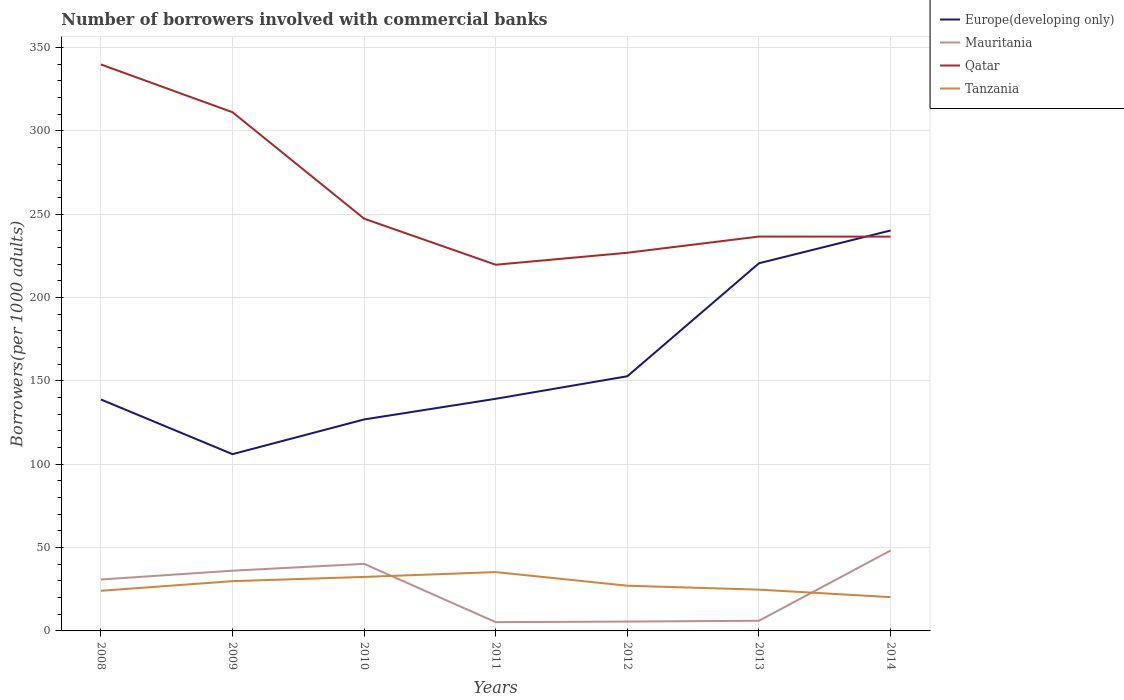How many different coloured lines are there?
Offer a terse response. 4. Across all years, what is the maximum number of borrowers involved with commercial banks in Mauritania?
Your answer should be compact. 5.26. In which year was the number of borrowers involved with commercial banks in Mauritania maximum?
Provide a succinct answer. 2011. What is the total number of borrowers involved with commercial banks in Europe(developing only) in the graph?
Your response must be concise. -93.7. What is the difference between the highest and the second highest number of borrowers involved with commercial banks in Tanzania?
Offer a terse response. 15.03. What is the difference between the highest and the lowest number of borrowers involved with commercial banks in Qatar?
Your answer should be very brief. 2. Is the number of borrowers involved with commercial banks in Mauritania strictly greater than the number of borrowers involved with commercial banks in Tanzania over the years?
Your answer should be very brief. No. Does the graph contain any zero values?
Give a very brief answer. No. Where does the legend appear in the graph?
Ensure brevity in your answer.  Top right. What is the title of the graph?
Keep it short and to the point. Number of borrowers involved with commercial banks. What is the label or title of the X-axis?
Offer a terse response. Years. What is the label or title of the Y-axis?
Give a very brief answer. Borrowers(per 1000 adults). What is the Borrowers(per 1000 adults) of Europe(developing only) in 2008?
Ensure brevity in your answer.  138.85. What is the Borrowers(per 1000 adults) in Mauritania in 2008?
Make the answer very short. 30.85. What is the Borrowers(per 1000 adults) in Qatar in 2008?
Make the answer very short. 339.83. What is the Borrowers(per 1000 adults) of Tanzania in 2008?
Offer a very short reply. 24.08. What is the Borrowers(per 1000 adults) of Europe(developing only) in 2009?
Give a very brief answer. 106.05. What is the Borrowers(per 1000 adults) of Mauritania in 2009?
Your answer should be compact. 36.13. What is the Borrowers(per 1000 adults) of Qatar in 2009?
Your answer should be very brief. 311.18. What is the Borrowers(per 1000 adults) of Tanzania in 2009?
Your response must be concise. 29.86. What is the Borrowers(per 1000 adults) of Europe(developing only) in 2010?
Provide a succinct answer. 126.87. What is the Borrowers(per 1000 adults) in Mauritania in 2010?
Provide a short and direct response. 40.23. What is the Borrowers(per 1000 adults) in Qatar in 2010?
Your response must be concise. 247.33. What is the Borrowers(per 1000 adults) in Tanzania in 2010?
Provide a succinct answer. 32.39. What is the Borrowers(per 1000 adults) in Europe(developing only) in 2011?
Make the answer very short. 139.27. What is the Borrowers(per 1000 adults) in Mauritania in 2011?
Your response must be concise. 5.26. What is the Borrowers(per 1000 adults) in Qatar in 2011?
Keep it short and to the point. 219.67. What is the Borrowers(per 1000 adults) of Tanzania in 2011?
Your answer should be very brief. 35.3. What is the Borrowers(per 1000 adults) in Europe(developing only) in 2012?
Keep it short and to the point. 152.78. What is the Borrowers(per 1000 adults) of Mauritania in 2012?
Your response must be concise. 5.62. What is the Borrowers(per 1000 adults) of Qatar in 2012?
Provide a succinct answer. 226.87. What is the Borrowers(per 1000 adults) of Tanzania in 2012?
Keep it short and to the point. 27.12. What is the Borrowers(per 1000 adults) in Europe(developing only) in 2013?
Provide a succinct answer. 220.56. What is the Borrowers(per 1000 adults) of Mauritania in 2013?
Your answer should be compact. 6.09. What is the Borrowers(per 1000 adults) in Qatar in 2013?
Make the answer very short. 236.58. What is the Borrowers(per 1000 adults) in Tanzania in 2013?
Make the answer very short. 24.77. What is the Borrowers(per 1000 adults) in Europe(developing only) in 2014?
Your answer should be very brief. 240.23. What is the Borrowers(per 1000 adults) in Mauritania in 2014?
Make the answer very short. 48.23. What is the Borrowers(per 1000 adults) in Qatar in 2014?
Offer a very short reply. 236.55. What is the Borrowers(per 1000 adults) of Tanzania in 2014?
Offer a very short reply. 20.27. Across all years, what is the maximum Borrowers(per 1000 adults) in Europe(developing only)?
Provide a succinct answer. 240.23. Across all years, what is the maximum Borrowers(per 1000 adults) of Mauritania?
Your answer should be compact. 48.23. Across all years, what is the maximum Borrowers(per 1000 adults) in Qatar?
Offer a very short reply. 339.83. Across all years, what is the maximum Borrowers(per 1000 adults) in Tanzania?
Provide a succinct answer. 35.3. Across all years, what is the minimum Borrowers(per 1000 adults) of Europe(developing only)?
Keep it short and to the point. 106.05. Across all years, what is the minimum Borrowers(per 1000 adults) in Mauritania?
Provide a short and direct response. 5.26. Across all years, what is the minimum Borrowers(per 1000 adults) of Qatar?
Ensure brevity in your answer.  219.67. Across all years, what is the minimum Borrowers(per 1000 adults) of Tanzania?
Your answer should be compact. 20.27. What is the total Borrowers(per 1000 adults) of Europe(developing only) in the graph?
Provide a succinct answer. 1124.6. What is the total Borrowers(per 1000 adults) of Mauritania in the graph?
Make the answer very short. 172.4. What is the total Borrowers(per 1000 adults) in Qatar in the graph?
Give a very brief answer. 1818.02. What is the total Borrowers(per 1000 adults) in Tanzania in the graph?
Provide a short and direct response. 193.77. What is the difference between the Borrowers(per 1000 adults) of Europe(developing only) in 2008 and that in 2009?
Keep it short and to the point. 32.8. What is the difference between the Borrowers(per 1000 adults) of Mauritania in 2008 and that in 2009?
Provide a succinct answer. -5.28. What is the difference between the Borrowers(per 1000 adults) in Qatar in 2008 and that in 2009?
Provide a short and direct response. 28.65. What is the difference between the Borrowers(per 1000 adults) of Tanzania in 2008 and that in 2009?
Provide a short and direct response. -5.78. What is the difference between the Borrowers(per 1000 adults) in Europe(developing only) in 2008 and that in 2010?
Ensure brevity in your answer.  11.98. What is the difference between the Borrowers(per 1000 adults) of Mauritania in 2008 and that in 2010?
Provide a short and direct response. -9.38. What is the difference between the Borrowers(per 1000 adults) in Qatar in 2008 and that in 2010?
Keep it short and to the point. 92.5. What is the difference between the Borrowers(per 1000 adults) in Tanzania in 2008 and that in 2010?
Your answer should be very brief. -8.32. What is the difference between the Borrowers(per 1000 adults) in Europe(developing only) in 2008 and that in 2011?
Keep it short and to the point. -0.42. What is the difference between the Borrowers(per 1000 adults) in Mauritania in 2008 and that in 2011?
Make the answer very short. 25.59. What is the difference between the Borrowers(per 1000 adults) of Qatar in 2008 and that in 2011?
Ensure brevity in your answer.  120.16. What is the difference between the Borrowers(per 1000 adults) of Tanzania in 2008 and that in 2011?
Provide a succinct answer. -11.22. What is the difference between the Borrowers(per 1000 adults) in Europe(developing only) in 2008 and that in 2012?
Ensure brevity in your answer.  -13.93. What is the difference between the Borrowers(per 1000 adults) in Mauritania in 2008 and that in 2012?
Offer a terse response. 25.23. What is the difference between the Borrowers(per 1000 adults) in Qatar in 2008 and that in 2012?
Offer a terse response. 112.96. What is the difference between the Borrowers(per 1000 adults) of Tanzania in 2008 and that in 2012?
Keep it short and to the point. -3.04. What is the difference between the Borrowers(per 1000 adults) of Europe(developing only) in 2008 and that in 2013?
Give a very brief answer. -81.71. What is the difference between the Borrowers(per 1000 adults) in Mauritania in 2008 and that in 2013?
Ensure brevity in your answer.  24.76. What is the difference between the Borrowers(per 1000 adults) of Qatar in 2008 and that in 2013?
Provide a succinct answer. 103.25. What is the difference between the Borrowers(per 1000 adults) of Tanzania in 2008 and that in 2013?
Provide a succinct answer. -0.69. What is the difference between the Borrowers(per 1000 adults) in Europe(developing only) in 2008 and that in 2014?
Offer a terse response. -101.38. What is the difference between the Borrowers(per 1000 adults) of Mauritania in 2008 and that in 2014?
Your answer should be compact. -17.38. What is the difference between the Borrowers(per 1000 adults) in Qatar in 2008 and that in 2014?
Keep it short and to the point. 103.28. What is the difference between the Borrowers(per 1000 adults) in Tanzania in 2008 and that in 2014?
Offer a terse response. 3.81. What is the difference between the Borrowers(per 1000 adults) of Europe(developing only) in 2009 and that in 2010?
Your response must be concise. -20.82. What is the difference between the Borrowers(per 1000 adults) in Mauritania in 2009 and that in 2010?
Ensure brevity in your answer.  -4.1. What is the difference between the Borrowers(per 1000 adults) of Qatar in 2009 and that in 2010?
Make the answer very short. 63.85. What is the difference between the Borrowers(per 1000 adults) of Tanzania in 2009 and that in 2010?
Provide a short and direct response. -2.54. What is the difference between the Borrowers(per 1000 adults) in Europe(developing only) in 2009 and that in 2011?
Offer a terse response. -33.22. What is the difference between the Borrowers(per 1000 adults) in Mauritania in 2009 and that in 2011?
Provide a short and direct response. 30.88. What is the difference between the Borrowers(per 1000 adults) in Qatar in 2009 and that in 2011?
Ensure brevity in your answer.  91.51. What is the difference between the Borrowers(per 1000 adults) of Tanzania in 2009 and that in 2011?
Ensure brevity in your answer.  -5.44. What is the difference between the Borrowers(per 1000 adults) in Europe(developing only) in 2009 and that in 2012?
Ensure brevity in your answer.  -46.73. What is the difference between the Borrowers(per 1000 adults) of Mauritania in 2009 and that in 2012?
Ensure brevity in your answer.  30.51. What is the difference between the Borrowers(per 1000 adults) of Qatar in 2009 and that in 2012?
Your answer should be compact. 84.31. What is the difference between the Borrowers(per 1000 adults) of Tanzania in 2009 and that in 2012?
Give a very brief answer. 2.74. What is the difference between the Borrowers(per 1000 adults) of Europe(developing only) in 2009 and that in 2013?
Provide a short and direct response. -114.52. What is the difference between the Borrowers(per 1000 adults) of Mauritania in 2009 and that in 2013?
Offer a very short reply. 30.04. What is the difference between the Borrowers(per 1000 adults) in Qatar in 2009 and that in 2013?
Ensure brevity in your answer.  74.6. What is the difference between the Borrowers(per 1000 adults) in Tanzania in 2009 and that in 2013?
Offer a very short reply. 5.09. What is the difference between the Borrowers(per 1000 adults) in Europe(developing only) in 2009 and that in 2014?
Make the answer very short. -134.19. What is the difference between the Borrowers(per 1000 adults) in Mauritania in 2009 and that in 2014?
Your answer should be very brief. -12.1. What is the difference between the Borrowers(per 1000 adults) of Qatar in 2009 and that in 2014?
Ensure brevity in your answer.  74.63. What is the difference between the Borrowers(per 1000 adults) in Tanzania in 2009 and that in 2014?
Make the answer very short. 9.59. What is the difference between the Borrowers(per 1000 adults) in Europe(developing only) in 2010 and that in 2011?
Your response must be concise. -12.4. What is the difference between the Borrowers(per 1000 adults) of Mauritania in 2010 and that in 2011?
Provide a succinct answer. 34.97. What is the difference between the Borrowers(per 1000 adults) in Qatar in 2010 and that in 2011?
Offer a terse response. 27.65. What is the difference between the Borrowers(per 1000 adults) in Tanzania in 2010 and that in 2011?
Give a very brief answer. -2.91. What is the difference between the Borrowers(per 1000 adults) in Europe(developing only) in 2010 and that in 2012?
Make the answer very short. -25.91. What is the difference between the Borrowers(per 1000 adults) in Mauritania in 2010 and that in 2012?
Keep it short and to the point. 34.61. What is the difference between the Borrowers(per 1000 adults) in Qatar in 2010 and that in 2012?
Give a very brief answer. 20.46. What is the difference between the Borrowers(per 1000 adults) of Tanzania in 2010 and that in 2012?
Ensure brevity in your answer.  5.28. What is the difference between the Borrowers(per 1000 adults) in Europe(developing only) in 2010 and that in 2013?
Offer a very short reply. -93.7. What is the difference between the Borrowers(per 1000 adults) in Mauritania in 2010 and that in 2013?
Offer a very short reply. 34.14. What is the difference between the Borrowers(per 1000 adults) of Qatar in 2010 and that in 2013?
Make the answer very short. 10.74. What is the difference between the Borrowers(per 1000 adults) in Tanzania in 2010 and that in 2013?
Your answer should be compact. 7.63. What is the difference between the Borrowers(per 1000 adults) in Europe(developing only) in 2010 and that in 2014?
Give a very brief answer. -113.37. What is the difference between the Borrowers(per 1000 adults) in Mauritania in 2010 and that in 2014?
Give a very brief answer. -8. What is the difference between the Borrowers(per 1000 adults) of Qatar in 2010 and that in 2014?
Your response must be concise. 10.78. What is the difference between the Borrowers(per 1000 adults) of Tanzania in 2010 and that in 2014?
Provide a succinct answer. 12.12. What is the difference between the Borrowers(per 1000 adults) in Europe(developing only) in 2011 and that in 2012?
Make the answer very short. -13.51. What is the difference between the Borrowers(per 1000 adults) of Mauritania in 2011 and that in 2012?
Provide a succinct answer. -0.36. What is the difference between the Borrowers(per 1000 adults) in Qatar in 2011 and that in 2012?
Offer a terse response. -7.2. What is the difference between the Borrowers(per 1000 adults) of Tanzania in 2011 and that in 2012?
Provide a short and direct response. 8.18. What is the difference between the Borrowers(per 1000 adults) of Europe(developing only) in 2011 and that in 2013?
Offer a terse response. -81.3. What is the difference between the Borrowers(per 1000 adults) of Mauritania in 2011 and that in 2013?
Provide a succinct answer. -0.83. What is the difference between the Borrowers(per 1000 adults) in Qatar in 2011 and that in 2013?
Keep it short and to the point. -16.91. What is the difference between the Borrowers(per 1000 adults) in Tanzania in 2011 and that in 2013?
Your answer should be very brief. 10.53. What is the difference between the Borrowers(per 1000 adults) in Europe(developing only) in 2011 and that in 2014?
Offer a terse response. -100.97. What is the difference between the Borrowers(per 1000 adults) of Mauritania in 2011 and that in 2014?
Offer a very short reply. -42.97. What is the difference between the Borrowers(per 1000 adults) of Qatar in 2011 and that in 2014?
Keep it short and to the point. -16.88. What is the difference between the Borrowers(per 1000 adults) of Tanzania in 2011 and that in 2014?
Make the answer very short. 15.03. What is the difference between the Borrowers(per 1000 adults) of Europe(developing only) in 2012 and that in 2013?
Keep it short and to the point. -67.78. What is the difference between the Borrowers(per 1000 adults) of Mauritania in 2012 and that in 2013?
Provide a succinct answer. -0.47. What is the difference between the Borrowers(per 1000 adults) in Qatar in 2012 and that in 2013?
Offer a terse response. -9.71. What is the difference between the Borrowers(per 1000 adults) in Tanzania in 2012 and that in 2013?
Your answer should be very brief. 2.35. What is the difference between the Borrowers(per 1000 adults) in Europe(developing only) in 2012 and that in 2014?
Provide a succinct answer. -87.45. What is the difference between the Borrowers(per 1000 adults) of Mauritania in 2012 and that in 2014?
Your answer should be compact. -42.61. What is the difference between the Borrowers(per 1000 adults) of Qatar in 2012 and that in 2014?
Ensure brevity in your answer.  -9.68. What is the difference between the Borrowers(per 1000 adults) of Tanzania in 2012 and that in 2014?
Give a very brief answer. 6.85. What is the difference between the Borrowers(per 1000 adults) of Europe(developing only) in 2013 and that in 2014?
Keep it short and to the point. -19.67. What is the difference between the Borrowers(per 1000 adults) in Mauritania in 2013 and that in 2014?
Your response must be concise. -42.14. What is the difference between the Borrowers(per 1000 adults) of Qatar in 2013 and that in 2014?
Provide a short and direct response. 0.04. What is the difference between the Borrowers(per 1000 adults) in Tanzania in 2013 and that in 2014?
Make the answer very short. 4.5. What is the difference between the Borrowers(per 1000 adults) of Europe(developing only) in 2008 and the Borrowers(per 1000 adults) of Mauritania in 2009?
Your answer should be very brief. 102.72. What is the difference between the Borrowers(per 1000 adults) of Europe(developing only) in 2008 and the Borrowers(per 1000 adults) of Qatar in 2009?
Provide a short and direct response. -172.33. What is the difference between the Borrowers(per 1000 adults) of Europe(developing only) in 2008 and the Borrowers(per 1000 adults) of Tanzania in 2009?
Offer a very short reply. 108.99. What is the difference between the Borrowers(per 1000 adults) of Mauritania in 2008 and the Borrowers(per 1000 adults) of Qatar in 2009?
Your answer should be compact. -280.33. What is the difference between the Borrowers(per 1000 adults) of Mauritania in 2008 and the Borrowers(per 1000 adults) of Tanzania in 2009?
Provide a succinct answer. 0.99. What is the difference between the Borrowers(per 1000 adults) of Qatar in 2008 and the Borrowers(per 1000 adults) of Tanzania in 2009?
Keep it short and to the point. 309.98. What is the difference between the Borrowers(per 1000 adults) of Europe(developing only) in 2008 and the Borrowers(per 1000 adults) of Mauritania in 2010?
Make the answer very short. 98.62. What is the difference between the Borrowers(per 1000 adults) in Europe(developing only) in 2008 and the Borrowers(per 1000 adults) in Qatar in 2010?
Give a very brief answer. -108.48. What is the difference between the Borrowers(per 1000 adults) in Europe(developing only) in 2008 and the Borrowers(per 1000 adults) in Tanzania in 2010?
Offer a very short reply. 106.46. What is the difference between the Borrowers(per 1000 adults) of Mauritania in 2008 and the Borrowers(per 1000 adults) of Qatar in 2010?
Give a very brief answer. -216.48. What is the difference between the Borrowers(per 1000 adults) of Mauritania in 2008 and the Borrowers(per 1000 adults) of Tanzania in 2010?
Provide a short and direct response. -1.54. What is the difference between the Borrowers(per 1000 adults) in Qatar in 2008 and the Borrowers(per 1000 adults) in Tanzania in 2010?
Your answer should be compact. 307.44. What is the difference between the Borrowers(per 1000 adults) in Europe(developing only) in 2008 and the Borrowers(per 1000 adults) in Mauritania in 2011?
Give a very brief answer. 133.59. What is the difference between the Borrowers(per 1000 adults) in Europe(developing only) in 2008 and the Borrowers(per 1000 adults) in Qatar in 2011?
Ensure brevity in your answer.  -80.82. What is the difference between the Borrowers(per 1000 adults) of Europe(developing only) in 2008 and the Borrowers(per 1000 adults) of Tanzania in 2011?
Make the answer very short. 103.55. What is the difference between the Borrowers(per 1000 adults) in Mauritania in 2008 and the Borrowers(per 1000 adults) in Qatar in 2011?
Offer a terse response. -188.83. What is the difference between the Borrowers(per 1000 adults) in Mauritania in 2008 and the Borrowers(per 1000 adults) in Tanzania in 2011?
Make the answer very short. -4.45. What is the difference between the Borrowers(per 1000 adults) of Qatar in 2008 and the Borrowers(per 1000 adults) of Tanzania in 2011?
Your answer should be very brief. 304.53. What is the difference between the Borrowers(per 1000 adults) of Europe(developing only) in 2008 and the Borrowers(per 1000 adults) of Mauritania in 2012?
Your response must be concise. 133.23. What is the difference between the Borrowers(per 1000 adults) of Europe(developing only) in 2008 and the Borrowers(per 1000 adults) of Qatar in 2012?
Offer a terse response. -88.02. What is the difference between the Borrowers(per 1000 adults) in Europe(developing only) in 2008 and the Borrowers(per 1000 adults) in Tanzania in 2012?
Your response must be concise. 111.73. What is the difference between the Borrowers(per 1000 adults) of Mauritania in 2008 and the Borrowers(per 1000 adults) of Qatar in 2012?
Your response must be concise. -196.02. What is the difference between the Borrowers(per 1000 adults) in Mauritania in 2008 and the Borrowers(per 1000 adults) in Tanzania in 2012?
Provide a short and direct response. 3.73. What is the difference between the Borrowers(per 1000 adults) of Qatar in 2008 and the Borrowers(per 1000 adults) of Tanzania in 2012?
Your response must be concise. 312.72. What is the difference between the Borrowers(per 1000 adults) of Europe(developing only) in 2008 and the Borrowers(per 1000 adults) of Mauritania in 2013?
Give a very brief answer. 132.76. What is the difference between the Borrowers(per 1000 adults) of Europe(developing only) in 2008 and the Borrowers(per 1000 adults) of Qatar in 2013?
Offer a very short reply. -97.74. What is the difference between the Borrowers(per 1000 adults) of Europe(developing only) in 2008 and the Borrowers(per 1000 adults) of Tanzania in 2013?
Offer a terse response. 114.08. What is the difference between the Borrowers(per 1000 adults) of Mauritania in 2008 and the Borrowers(per 1000 adults) of Qatar in 2013?
Your response must be concise. -205.74. What is the difference between the Borrowers(per 1000 adults) in Mauritania in 2008 and the Borrowers(per 1000 adults) in Tanzania in 2013?
Provide a succinct answer. 6.08. What is the difference between the Borrowers(per 1000 adults) in Qatar in 2008 and the Borrowers(per 1000 adults) in Tanzania in 2013?
Provide a short and direct response. 315.07. What is the difference between the Borrowers(per 1000 adults) of Europe(developing only) in 2008 and the Borrowers(per 1000 adults) of Mauritania in 2014?
Your answer should be very brief. 90.62. What is the difference between the Borrowers(per 1000 adults) of Europe(developing only) in 2008 and the Borrowers(per 1000 adults) of Qatar in 2014?
Keep it short and to the point. -97.7. What is the difference between the Borrowers(per 1000 adults) in Europe(developing only) in 2008 and the Borrowers(per 1000 adults) in Tanzania in 2014?
Make the answer very short. 118.58. What is the difference between the Borrowers(per 1000 adults) in Mauritania in 2008 and the Borrowers(per 1000 adults) in Qatar in 2014?
Your answer should be very brief. -205.7. What is the difference between the Borrowers(per 1000 adults) of Mauritania in 2008 and the Borrowers(per 1000 adults) of Tanzania in 2014?
Keep it short and to the point. 10.58. What is the difference between the Borrowers(per 1000 adults) of Qatar in 2008 and the Borrowers(per 1000 adults) of Tanzania in 2014?
Keep it short and to the point. 319.56. What is the difference between the Borrowers(per 1000 adults) in Europe(developing only) in 2009 and the Borrowers(per 1000 adults) in Mauritania in 2010?
Your answer should be very brief. 65.82. What is the difference between the Borrowers(per 1000 adults) in Europe(developing only) in 2009 and the Borrowers(per 1000 adults) in Qatar in 2010?
Give a very brief answer. -141.28. What is the difference between the Borrowers(per 1000 adults) in Europe(developing only) in 2009 and the Borrowers(per 1000 adults) in Tanzania in 2010?
Give a very brief answer. 73.65. What is the difference between the Borrowers(per 1000 adults) in Mauritania in 2009 and the Borrowers(per 1000 adults) in Qatar in 2010?
Provide a succinct answer. -211.2. What is the difference between the Borrowers(per 1000 adults) of Mauritania in 2009 and the Borrowers(per 1000 adults) of Tanzania in 2010?
Your answer should be compact. 3.74. What is the difference between the Borrowers(per 1000 adults) in Qatar in 2009 and the Borrowers(per 1000 adults) in Tanzania in 2010?
Ensure brevity in your answer.  278.79. What is the difference between the Borrowers(per 1000 adults) in Europe(developing only) in 2009 and the Borrowers(per 1000 adults) in Mauritania in 2011?
Offer a very short reply. 100.79. What is the difference between the Borrowers(per 1000 adults) of Europe(developing only) in 2009 and the Borrowers(per 1000 adults) of Qatar in 2011?
Provide a succinct answer. -113.63. What is the difference between the Borrowers(per 1000 adults) in Europe(developing only) in 2009 and the Borrowers(per 1000 adults) in Tanzania in 2011?
Give a very brief answer. 70.75. What is the difference between the Borrowers(per 1000 adults) of Mauritania in 2009 and the Borrowers(per 1000 adults) of Qatar in 2011?
Provide a succinct answer. -183.54. What is the difference between the Borrowers(per 1000 adults) in Mauritania in 2009 and the Borrowers(per 1000 adults) in Tanzania in 2011?
Your answer should be compact. 0.83. What is the difference between the Borrowers(per 1000 adults) in Qatar in 2009 and the Borrowers(per 1000 adults) in Tanzania in 2011?
Make the answer very short. 275.88. What is the difference between the Borrowers(per 1000 adults) in Europe(developing only) in 2009 and the Borrowers(per 1000 adults) in Mauritania in 2012?
Offer a terse response. 100.43. What is the difference between the Borrowers(per 1000 adults) of Europe(developing only) in 2009 and the Borrowers(per 1000 adults) of Qatar in 2012?
Make the answer very short. -120.83. What is the difference between the Borrowers(per 1000 adults) in Europe(developing only) in 2009 and the Borrowers(per 1000 adults) in Tanzania in 2012?
Your answer should be compact. 78.93. What is the difference between the Borrowers(per 1000 adults) in Mauritania in 2009 and the Borrowers(per 1000 adults) in Qatar in 2012?
Your answer should be very brief. -190.74. What is the difference between the Borrowers(per 1000 adults) in Mauritania in 2009 and the Borrowers(per 1000 adults) in Tanzania in 2012?
Provide a short and direct response. 9.02. What is the difference between the Borrowers(per 1000 adults) in Qatar in 2009 and the Borrowers(per 1000 adults) in Tanzania in 2012?
Ensure brevity in your answer.  284.07. What is the difference between the Borrowers(per 1000 adults) of Europe(developing only) in 2009 and the Borrowers(per 1000 adults) of Mauritania in 2013?
Offer a terse response. 99.96. What is the difference between the Borrowers(per 1000 adults) of Europe(developing only) in 2009 and the Borrowers(per 1000 adults) of Qatar in 2013?
Give a very brief answer. -130.54. What is the difference between the Borrowers(per 1000 adults) of Europe(developing only) in 2009 and the Borrowers(per 1000 adults) of Tanzania in 2013?
Provide a succinct answer. 81.28. What is the difference between the Borrowers(per 1000 adults) of Mauritania in 2009 and the Borrowers(per 1000 adults) of Qatar in 2013?
Your answer should be very brief. -200.45. What is the difference between the Borrowers(per 1000 adults) of Mauritania in 2009 and the Borrowers(per 1000 adults) of Tanzania in 2013?
Give a very brief answer. 11.37. What is the difference between the Borrowers(per 1000 adults) in Qatar in 2009 and the Borrowers(per 1000 adults) in Tanzania in 2013?
Ensure brevity in your answer.  286.42. What is the difference between the Borrowers(per 1000 adults) in Europe(developing only) in 2009 and the Borrowers(per 1000 adults) in Mauritania in 2014?
Offer a very short reply. 57.82. What is the difference between the Borrowers(per 1000 adults) in Europe(developing only) in 2009 and the Borrowers(per 1000 adults) in Qatar in 2014?
Give a very brief answer. -130.5. What is the difference between the Borrowers(per 1000 adults) in Europe(developing only) in 2009 and the Borrowers(per 1000 adults) in Tanzania in 2014?
Provide a succinct answer. 85.78. What is the difference between the Borrowers(per 1000 adults) of Mauritania in 2009 and the Borrowers(per 1000 adults) of Qatar in 2014?
Provide a succinct answer. -200.42. What is the difference between the Borrowers(per 1000 adults) of Mauritania in 2009 and the Borrowers(per 1000 adults) of Tanzania in 2014?
Provide a succinct answer. 15.86. What is the difference between the Borrowers(per 1000 adults) of Qatar in 2009 and the Borrowers(per 1000 adults) of Tanzania in 2014?
Your answer should be compact. 290.91. What is the difference between the Borrowers(per 1000 adults) of Europe(developing only) in 2010 and the Borrowers(per 1000 adults) of Mauritania in 2011?
Give a very brief answer. 121.61. What is the difference between the Borrowers(per 1000 adults) in Europe(developing only) in 2010 and the Borrowers(per 1000 adults) in Qatar in 2011?
Your answer should be compact. -92.81. What is the difference between the Borrowers(per 1000 adults) in Europe(developing only) in 2010 and the Borrowers(per 1000 adults) in Tanzania in 2011?
Offer a very short reply. 91.57. What is the difference between the Borrowers(per 1000 adults) of Mauritania in 2010 and the Borrowers(per 1000 adults) of Qatar in 2011?
Your response must be concise. -179.44. What is the difference between the Borrowers(per 1000 adults) of Mauritania in 2010 and the Borrowers(per 1000 adults) of Tanzania in 2011?
Make the answer very short. 4.93. What is the difference between the Borrowers(per 1000 adults) in Qatar in 2010 and the Borrowers(per 1000 adults) in Tanzania in 2011?
Keep it short and to the point. 212.03. What is the difference between the Borrowers(per 1000 adults) of Europe(developing only) in 2010 and the Borrowers(per 1000 adults) of Mauritania in 2012?
Make the answer very short. 121.25. What is the difference between the Borrowers(per 1000 adults) of Europe(developing only) in 2010 and the Borrowers(per 1000 adults) of Qatar in 2012?
Provide a short and direct response. -100.01. What is the difference between the Borrowers(per 1000 adults) in Europe(developing only) in 2010 and the Borrowers(per 1000 adults) in Tanzania in 2012?
Ensure brevity in your answer.  99.75. What is the difference between the Borrowers(per 1000 adults) in Mauritania in 2010 and the Borrowers(per 1000 adults) in Qatar in 2012?
Make the answer very short. -186.64. What is the difference between the Borrowers(per 1000 adults) in Mauritania in 2010 and the Borrowers(per 1000 adults) in Tanzania in 2012?
Your answer should be compact. 13.11. What is the difference between the Borrowers(per 1000 adults) in Qatar in 2010 and the Borrowers(per 1000 adults) in Tanzania in 2012?
Give a very brief answer. 220.21. What is the difference between the Borrowers(per 1000 adults) of Europe(developing only) in 2010 and the Borrowers(per 1000 adults) of Mauritania in 2013?
Keep it short and to the point. 120.78. What is the difference between the Borrowers(per 1000 adults) in Europe(developing only) in 2010 and the Borrowers(per 1000 adults) in Qatar in 2013?
Your response must be concise. -109.72. What is the difference between the Borrowers(per 1000 adults) in Europe(developing only) in 2010 and the Borrowers(per 1000 adults) in Tanzania in 2013?
Keep it short and to the point. 102.1. What is the difference between the Borrowers(per 1000 adults) of Mauritania in 2010 and the Borrowers(per 1000 adults) of Qatar in 2013?
Offer a terse response. -196.35. What is the difference between the Borrowers(per 1000 adults) of Mauritania in 2010 and the Borrowers(per 1000 adults) of Tanzania in 2013?
Offer a terse response. 15.46. What is the difference between the Borrowers(per 1000 adults) in Qatar in 2010 and the Borrowers(per 1000 adults) in Tanzania in 2013?
Your answer should be compact. 222.56. What is the difference between the Borrowers(per 1000 adults) in Europe(developing only) in 2010 and the Borrowers(per 1000 adults) in Mauritania in 2014?
Keep it short and to the point. 78.64. What is the difference between the Borrowers(per 1000 adults) in Europe(developing only) in 2010 and the Borrowers(per 1000 adults) in Qatar in 2014?
Make the answer very short. -109.68. What is the difference between the Borrowers(per 1000 adults) in Europe(developing only) in 2010 and the Borrowers(per 1000 adults) in Tanzania in 2014?
Offer a terse response. 106.6. What is the difference between the Borrowers(per 1000 adults) of Mauritania in 2010 and the Borrowers(per 1000 adults) of Qatar in 2014?
Keep it short and to the point. -196.32. What is the difference between the Borrowers(per 1000 adults) of Mauritania in 2010 and the Borrowers(per 1000 adults) of Tanzania in 2014?
Your answer should be compact. 19.96. What is the difference between the Borrowers(per 1000 adults) of Qatar in 2010 and the Borrowers(per 1000 adults) of Tanzania in 2014?
Your answer should be compact. 227.06. What is the difference between the Borrowers(per 1000 adults) of Europe(developing only) in 2011 and the Borrowers(per 1000 adults) of Mauritania in 2012?
Offer a very short reply. 133.65. What is the difference between the Borrowers(per 1000 adults) of Europe(developing only) in 2011 and the Borrowers(per 1000 adults) of Qatar in 2012?
Offer a terse response. -87.61. What is the difference between the Borrowers(per 1000 adults) in Europe(developing only) in 2011 and the Borrowers(per 1000 adults) in Tanzania in 2012?
Make the answer very short. 112.15. What is the difference between the Borrowers(per 1000 adults) of Mauritania in 2011 and the Borrowers(per 1000 adults) of Qatar in 2012?
Your answer should be compact. -221.62. What is the difference between the Borrowers(per 1000 adults) of Mauritania in 2011 and the Borrowers(per 1000 adults) of Tanzania in 2012?
Provide a short and direct response. -21.86. What is the difference between the Borrowers(per 1000 adults) in Qatar in 2011 and the Borrowers(per 1000 adults) in Tanzania in 2012?
Ensure brevity in your answer.  192.56. What is the difference between the Borrowers(per 1000 adults) of Europe(developing only) in 2011 and the Borrowers(per 1000 adults) of Mauritania in 2013?
Your answer should be very brief. 133.18. What is the difference between the Borrowers(per 1000 adults) of Europe(developing only) in 2011 and the Borrowers(per 1000 adults) of Qatar in 2013?
Your answer should be very brief. -97.32. What is the difference between the Borrowers(per 1000 adults) in Europe(developing only) in 2011 and the Borrowers(per 1000 adults) in Tanzania in 2013?
Offer a very short reply. 114.5. What is the difference between the Borrowers(per 1000 adults) in Mauritania in 2011 and the Borrowers(per 1000 adults) in Qatar in 2013?
Make the answer very short. -231.33. What is the difference between the Borrowers(per 1000 adults) of Mauritania in 2011 and the Borrowers(per 1000 adults) of Tanzania in 2013?
Your response must be concise. -19.51. What is the difference between the Borrowers(per 1000 adults) of Qatar in 2011 and the Borrowers(per 1000 adults) of Tanzania in 2013?
Provide a short and direct response. 194.91. What is the difference between the Borrowers(per 1000 adults) of Europe(developing only) in 2011 and the Borrowers(per 1000 adults) of Mauritania in 2014?
Provide a succinct answer. 91.04. What is the difference between the Borrowers(per 1000 adults) of Europe(developing only) in 2011 and the Borrowers(per 1000 adults) of Qatar in 2014?
Your answer should be very brief. -97.28. What is the difference between the Borrowers(per 1000 adults) of Europe(developing only) in 2011 and the Borrowers(per 1000 adults) of Tanzania in 2014?
Provide a short and direct response. 119. What is the difference between the Borrowers(per 1000 adults) in Mauritania in 2011 and the Borrowers(per 1000 adults) in Qatar in 2014?
Your response must be concise. -231.29. What is the difference between the Borrowers(per 1000 adults) in Mauritania in 2011 and the Borrowers(per 1000 adults) in Tanzania in 2014?
Provide a short and direct response. -15.01. What is the difference between the Borrowers(per 1000 adults) in Qatar in 2011 and the Borrowers(per 1000 adults) in Tanzania in 2014?
Make the answer very short. 199.4. What is the difference between the Borrowers(per 1000 adults) of Europe(developing only) in 2012 and the Borrowers(per 1000 adults) of Mauritania in 2013?
Offer a very short reply. 146.69. What is the difference between the Borrowers(per 1000 adults) in Europe(developing only) in 2012 and the Borrowers(per 1000 adults) in Qatar in 2013?
Your answer should be compact. -83.8. What is the difference between the Borrowers(per 1000 adults) of Europe(developing only) in 2012 and the Borrowers(per 1000 adults) of Tanzania in 2013?
Make the answer very short. 128.02. What is the difference between the Borrowers(per 1000 adults) of Mauritania in 2012 and the Borrowers(per 1000 adults) of Qatar in 2013?
Offer a very short reply. -230.97. What is the difference between the Borrowers(per 1000 adults) in Mauritania in 2012 and the Borrowers(per 1000 adults) in Tanzania in 2013?
Offer a terse response. -19.15. What is the difference between the Borrowers(per 1000 adults) of Qatar in 2012 and the Borrowers(per 1000 adults) of Tanzania in 2013?
Your answer should be compact. 202.11. What is the difference between the Borrowers(per 1000 adults) in Europe(developing only) in 2012 and the Borrowers(per 1000 adults) in Mauritania in 2014?
Make the answer very short. 104.55. What is the difference between the Borrowers(per 1000 adults) of Europe(developing only) in 2012 and the Borrowers(per 1000 adults) of Qatar in 2014?
Offer a very short reply. -83.77. What is the difference between the Borrowers(per 1000 adults) of Europe(developing only) in 2012 and the Borrowers(per 1000 adults) of Tanzania in 2014?
Your answer should be very brief. 132.51. What is the difference between the Borrowers(per 1000 adults) of Mauritania in 2012 and the Borrowers(per 1000 adults) of Qatar in 2014?
Provide a succinct answer. -230.93. What is the difference between the Borrowers(per 1000 adults) of Mauritania in 2012 and the Borrowers(per 1000 adults) of Tanzania in 2014?
Make the answer very short. -14.65. What is the difference between the Borrowers(per 1000 adults) of Qatar in 2012 and the Borrowers(per 1000 adults) of Tanzania in 2014?
Provide a short and direct response. 206.6. What is the difference between the Borrowers(per 1000 adults) of Europe(developing only) in 2013 and the Borrowers(per 1000 adults) of Mauritania in 2014?
Give a very brief answer. 172.33. What is the difference between the Borrowers(per 1000 adults) of Europe(developing only) in 2013 and the Borrowers(per 1000 adults) of Qatar in 2014?
Provide a short and direct response. -15.99. What is the difference between the Borrowers(per 1000 adults) in Europe(developing only) in 2013 and the Borrowers(per 1000 adults) in Tanzania in 2014?
Ensure brevity in your answer.  200.29. What is the difference between the Borrowers(per 1000 adults) in Mauritania in 2013 and the Borrowers(per 1000 adults) in Qatar in 2014?
Your response must be concise. -230.46. What is the difference between the Borrowers(per 1000 adults) of Mauritania in 2013 and the Borrowers(per 1000 adults) of Tanzania in 2014?
Provide a short and direct response. -14.18. What is the difference between the Borrowers(per 1000 adults) of Qatar in 2013 and the Borrowers(per 1000 adults) of Tanzania in 2014?
Your response must be concise. 216.31. What is the average Borrowers(per 1000 adults) of Europe(developing only) per year?
Your answer should be compact. 160.66. What is the average Borrowers(per 1000 adults) in Mauritania per year?
Your answer should be very brief. 24.63. What is the average Borrowers(per 1000 adults) of Qatar per year?
Provide a short and direct response. 259.72. What is the average Borrowers(per 1000 adults) in Tanzania per year?
Make the answer very short. 27.68. In the year 2008, what is the difference between the Borrowers(per 1000 adults) of Europe(developing only) and Borrowers(per 1000 adults) of Mauritania?
Make the answer very short. 108. In the year 2008, what is the difference between the Borrowers(per 1000 adults) of Europe(developing only) and Borrowers(per 1000 adults) of Qatar?
Your response must be concise. -200.98. In the year 2008, what is the difference between the Borrowers(per 1000 adults) in Europe(developing only) and Borrowers(per 1000 adults) in Tanzania?
Your response must be concise. 114.77. In the year 2008, what is the difference between the Borrowers(per 1000 adults) in Mauritania and Borrowers(per 1000 adults) in Qatar?
Ensure brevity in your answer.  -308.98. In the year 2008, what is the difference between the Borrowers(per 1000 adults) in Mauritania and Borrowers(per 1000 adults) in Tanzania?
Provide a succinct answer. 6.77. In the year 2008, what is the difference between the Borrowers(per 1000 adults) in Qatar and Borrowers(per 1000 adults) in Tanzania?
Give a very brief answer. 315.76. In the year 2009, what is the difference between the Borrowers(per 1000 adults) in Europe(developing only) and Borrowers(per 1000 adults) in Mauritania?
Keep it short and to the point. 69.91. In the year 2009, what is the difference between the Borrowers(per 1000 adults) of Europe(developing only) and Borrowers(per 1000 adults) of Qatar?
Offer a very short reply. -205.14. In the year 2009, what is the difference between the Borrowers(per 1000 adults) in Europe(developing only) and Borrowers(per 1000 adults) in Tanzania?
Offer a terse response. 76.19. In the year 2009, what is the difference between the Borrowers(per 1000 adults) of Mauritania and Borrowers(per 1000 adults) of Qatar?
Provide a succinct answer. -275.05. In the year 2009, what is the difference between the Borrowers(per 1000 adults) of Mauritania and Borrowers(per 1000 adults) of Tanzania?
Ensure brevity in your answer.  6.28. In the year 2009, what is the difference between the Borrowers(per 1000 adults) in Qatar and Borrowers(per 1000 adults) in Tanzania?
Offer a very short reply. 281.33. In the year 2010, what is the difference between the Borrowers(per 1000 adults) in Europe(developing only) and Borrowers(per 1000 adults) in Mauritania?
Provide a succinct answer. 86.64. In the year 2010, what is the difference between the Borrowers(per 1000 adults) in Europe(developing only) and Borrowers(per 1000 adults) in Qatar?
Keep it short and to the point. -120.46. In the year 2010, what is the difference between the Borrowers(per 1000 adults) in Europe(developing only) and Borrowers(per 1000 adults) in Tanzania?
Your answer should be compact. 94.48. In the year 2010, what is the difference between the Borrowers(per 1000 adults) in Mauritania and Borrowers(per 1000 adults) in Qatar?
Provide a succinct answer. -207.1. In the year 2010, what is the difference between the Borrowers(per 1000 adults) of Mauritania and Borrowers(per 1000 adults) of Tanzania?
Your answer should be very brief. 7.84. In the year 2010, what is the difference between the Borrowers(per 1000 adults) of Qatar and Borrowers(per 1000 adults) of Tanzania?
Your answer should be compact. 214.94. In the year 2011, what is the difference between the Borrowers(per 1000 adults) of Europe(developing only) and Borrowers(per 1000 adults) of Mauritania?
Give a very brief answer. 134.01. In the year 2011, what is the difference between the Borrowers(per 1000 adults) of Europe(developing only) and Borrowers(per 1000 adults) of Qatar?
Your answer should be compact. -80.41. In the year 2011, what is the difference between the Borrowers(per 1000 adults) in Europe(developing only) and Borrowers(per 1000 adults) in Tanzania?
Provide a succinct answer. 103.97. In the year 2011, what is the difference between the Borrowers(per 1000 adults) in Mauritania and Borrowers(per 1000 adults) in Qatar?
Your answer should be compact. -214.42. In the year 2011, what is the difference between the Borrowers(per 1000 adults) of Mauritania and Borrowers(per 1000 adults) of Tanzania?
Provide a succinct answer. -30.04. In the year 2011, what is the difference between the Borrowers(per 1000 adults) of Qatar and Borrowers(per 1000 adults) of Tanzania?
Your answer should be compact. 184.38. In the year 2012, what is the difference between the Borrowers(per 1000 adults) of Europe(developing only) and Borrowers(per 1000 adults) of Mauritania?
Offer a very short reply. 147.16. In the year 2012, what is the difference between the Borrowers(per 1000 adults) of Europe(developing only) and Borrowers(per 1000 adults) of Qatar?
Your answer should be compact. -74.09. In the year 2012, what is the difference between the Borrowers(per 1000 adults) of Europe(developing only) and Borrowers(per 1000 adults) of Tanzania?
Ensure brevity in your answer.  125.67. In the year 2012, what is the difference between the Borrowers(per 1000 adults) of Mauritania and Borrowers(per 1000 adults) of Qatar?
Offer a very short reply. -221.26. In the year 2012, what is the difference between the Borrowers(per 1000 adults) of Mauritania and Borrowers(per 1000 adults) of Tanzania?
Offer a terse response. -21.5. In the year 2012, what is the difference between the Borrowers(per 1000 adults) of Qatar and Borrowers(per 1000 adults) of Tanzania?
Provide a succinct answer. 199.76. In the year 2013, what is the difference between the Borrowers(per 1000 adults) in Europe(developing only) and Borrowers(per 1000 adults) in Mauritania?
Provide a short and direct response. 214.47. In the year 2013, what is the difference between the Borrowers(per 1000 adults) of Europe(developing only) and Borrowers(per 1000 adults) of Qatar?
Your response must be concise. -16.02. In the year 2013, what is the difference between the Borrowers(per 1000 adults) of Europe(developing only) and Borrowers(per 1000 adults) of Tanzania?
Give a very brief answer. 195.8. In the year 2013, what is the difference between the Borrowers(per 1000 adults) in Mauritania and Borrowers(per 1000 adults) in Qatar?
Provide a short and direct response. -230.5. In the year 2013, what is the difference between the Borrowers(per 1000 adults) of Mauritania and Borrowers(per 1000 adults) of Tanzania?
Offer a very short reply. -18.68. In the year 2013, what is the difference between the Borrowers(per 1000 adults) of Qatar and Borrowers(per 1000 adults) of Tanzania?
Provide a short and direct response. 211.82. In the year 2014, what is the difference between the Borrowers(per 1000 adults) in Europe(developing only) and Borrowers(per 1000 adults) in Mauritania?
Your answer should be very brief. 192. In the year 2014, what is the difference between the Borrowers(per 1000 adults) in Europe(developing only) and Borrowers(per 1000 adults) in Qatar?
Offer a very short reply. 3.68. In the year 2014, what is the difference between the Borrowers(per 1000 adults) in Europe(developing only) and Borrowers(per 1000 adults) in Tanzania?
Ensure brevity in your answer.  219.96. In the year 2014, what is the difference between the Borrowers(per 1000 adults) in Mauritania and Borrowers(per 1000 adults) in Qatar?
Provide a short and direct response. -188.32. In the year 2014, what is the difference between the Borrowers(per 1000 adults) in Mauritania and Borrowers(per 1000 adults) in Tanzania?
Provide a short and direct response. 27.96. In the year 2014, what is the difference between the Borrowers(per 1000 adults) in Qatar and Borrowers(per 1000 adults) in Tanzania?
Offer a very short reply. 216.28. What is the ratio of the Borrowers(per 1000 adults) in Europe(developing only) in 2008 to that in 2009?
Ensure brevity in your answer.  1.31. What is the ratio of the Borrowers(per 1000 adults) of Mauritania in 2008 to that in 2009?
Keep it short and to the point. 0.85. What is the ratio of the Borrowers(per 1000 adults) in Qatar in 2008 to that in 2009?
Offer a terse response. 1.09. What is the ratio of the Borrowers(per 1000 adults) in Tanzania in 2008 to that in 2009?
Ensure brevity in your answer.  0.81. What is the ratio of the Borrowers(per 1000 adults) in Europe(developing only) in 2008 to that in 2010?
Make the answer very short. 1.09. What is the ratio of the Borrowers(per 1000 adults) in Mauritania in 2008 to that in 2010?
Provide a succinct answer. 0.77. What is the ratio of the Borrowers(per 1000 adults) in Qatar in 2008 to that in 2010?
Your response must be concise. 1.37. What is the ratio of the Borrowers(per 1000 adults) in Tanzania in 2008 to that in 2010?
Ensure brevity in your answer.  0.74. What is the ratio of the Borrowers(per 1000 adults) in Mauritania in 2008 to that in 2011?
Make the answer very short. 5.87. What is the ratio of the Borrowers(per 1000 adults) of Qatar in 2008 to that in 2011?
Your answer should be very brief. 1.55. What is the ratio of the Borrowers(per 1000 adults) in Tanzania in 2008 to that in 2011?
Your answer should be very brief. 0.68. What is the ratio of the Borrowers(per 1000 adults) in Europe(developing only) in 2008 to that in 2012?
Your answer should be compact. 0.91. What is the ratio of the Borrowers(per 1000 adults) in Mauritania in 2008 to that in 2012?
Your response must be concise. 5.49. What is the ratio of the Borrowers(per 1000 adults) of Qatar in 2008 to that in 2012?
Make the answer very short. 1.5. What is the ratio of the Borrowers(per 1000 adults) in Tanzania in 2008 to that in 2012?
Make the answer very short. 0.89. What is the ratio of the Borrowers(per 1000 adults) in Europe(developing only) in 2008 to that in 2013?
Make the answer very short. 0.63. What is the ratio of the Borrowers(per 1000 adults) in Mauritania in 2008 to that in 2013?
Offer a very short reply. 5.07. What is the ratio of the Borrowers(per 1000 adults) in Qatar in 2008 to that in 2013?
Your answer should be compact. 1.44. What is the ratio of the Borrowers(per 1000 adults) of Tanzania in 2008 to that in 2013?
Ensure brevity in your answer.  0.97. What is the ratio of the Borrowers(per 1000 adults) in Europe(developing only) in 2008 to that in 2014?
Keep it short and to the point. 0.58. What is the ratio of the Borrowers(per 1000 adults) in Mauritania in 2008 to that in 2014?
Offer a terse response. 0.64. What is the ratio of the Borrowers(per 1000 adults) in Qatar in 2008 to that in 2014?
Your answer should be very brief. 1.44. What is the ratio of the Borrowers(per 1000 adults) of Tanzania in 2008 to that in 2014?
Give a very brief answer. 1.19. What is the ratio of the Borrowers(per 1000 adults) of Europe(developing only) in 2009 to that in 2010?
Provide a short and direct response. 0.84. What is the ratio of the Borrowers(per 1000 adults) of Mauritania in 2009 to that in 2010?
Offer a very short reply. 0.9. What is the ratio of the Borrowers(per 1000 adults) of Qatar in 2009 to that in 2010?
Offer a terse response. 1.26. What is the ratio of the Borrowers(per 1000 adults) of Tanzania in 2009 to that in 2010?
Your answer should be compact. 0.92. What is the ratio of the Borrowers(per 1000 adults) of Europe(developing only) in 2009 to that in 2011?
Your response must be concise. 0.76. What is the ratio of the Borrowers(per 1000 adults) in Mauritania in 2009 to that in 2011?
Ensure brevity in your answer.  6.87. What is the ratio of the Borrowers(per 1000 adults) of Qatar in 2009 to that in 2011?
Your answer should be very brief. 1.42. What is the ratio of the Borrowers(per 1000 adults) of Tanzania in 2009 to that in 2011?
Your answer should be very brief. 0.85. What is the ratio of the Borrowers(per 1000 adults) in Europe(developing only) in 2009 to that in 2012?
Offer a terse response. 0.69. What is the ratio of the Borrowers(per 1000 adults) of Mauritania in 2009 to that in 2012?
Your answer should be compact. 6.43. What is the ratio of the Borrowers(per 1000 adults) in Qatar in 2009 to that in 2012?
Keep it short and to the point. 1.37. What is the ratio of the Borrowers(per 1000 adults) in Tanzania in 2009 to that in 2012?
Your answer should be very brief. 1.1. What is the ratio of the Borrowers(per 1000 adults) of Europe(developing only) in 2009 to that in 2013?
Provide a succinct answer. 0.48. What is the ratio of the Borrowers(per 1000 adults) of Mauritania in 2009 to that in 2013?
Provide a short and direct response. 5.93. What is the ratio of the Borrowers(per 1000 adults) in Qatar in 2009 to that in 2013?
Provide a succinct answer. 1.32. What is the ratio of the Borrowers(per 1000 adults) of Tanzania in 2009 to that in 2013?
Your answer should be very brief. 1.21. What is the ratio of the Borrowers(per 1000 adults) in Europe(developing only) in 2009 to that in 2014?
Make the answer very short. 0.44. What is the ratio of the Borrowers(per 1000 adults) of Mauritania in 2009 to that in 2014?
Provide a succinct answer. 0.75. What is the ratio of the Borrowers(per 1000 adults) in Qatar in 2009 to that in 2014?
Your answer should be very brief. 1.32. What is the ratio of the Borrowers(per 1000 adults) in Tanzania in 2009 to that in 2014?
Provide a short and direct response. 1.47. What is the ratio of the Borrowers(per 1000 adults) of Europe(developing only) in 2010 to that in 2011?
Give a very brief answer. 0.91. What is the ratio of the Borrowers(per 1000 adults) of Mauritania in 2010 to that in 2011?
Provide a short and direct response. 7.65. What is the ratio of the Borrowers(per 1000 adults) in Qatar in 2010 to that in 2011?
Provide a short and direct response. 1.13. What is the ratio of the Borrowers(per 1000 adults) in Tanzania in 2010 to that in 2011?
Your response must be concise. 0.92. What is the ratio of the Borrowers(per 1000 adults) of Europe(developing only) in 2010 to that in 2012?
Ensure brevity in your answer.  0.83. What is the ratio of the Borrowers(per 1000 adults) in Mauritania in 2010 to that in 2012?
Your response must be concise. 7.16. What is the ratio of the Borrowers(per 1000 adults) in Qatar in 2010 to that in 2012?
Provide a short and direct response. 1.09. What is the ratio of the Borrowers(per 1000 adults) of Tanzania in 2010 to that in 2012?
Offer a very short reply. 1.19. What is the ratio of the Borrowers(per 1000 adults) of Europe(developing only) in 2010 to that in 2013?
Offer a terse response. 0.58. What is the ratio of the Borrowers(per 1000 adults) of Mauritania in 2010 to that in 2013?
Make the answer very short. 6.61. What is the ratio of the Borrowers(per 1000 adults) in Qatar in 2010 to that in 2013?
Provide a succinct answer. 1.05. What is the ratio of the Borrowers(per 1000 adults) of Tanzania in 2010 to that in 2013?
Ensure brevity in your answer.  1.31. What is the ratio of the Borrowers(per 1000 adults) of Europe(developing only) in 2010 to that in 2014?
Make the answer very short. 0.53. What is the ratio of the Borrowers(per 1000 adults) in Mauritania in 2010 to that in 2014?
Offer a terse response. 0.83. What is the ratio of the Borrowers(per 1000 adults) in Qatar in 2010 to that in 2014?
Your response must be concise. 1.05. What is the ratio of the Borrowers(per 1000 adults) of Tanzania in 2010 to that in 2014?
Ensure brevity in your answer.  1.6. What is the ratio of the Borrowers(per 1000 adults) in Europe(developing only) in 2011 to that in 2012?
Your answer should be compact. 0.91. What is the ratio of the Borrowers(per 1000 adults) in Mauritania in 2011 to that in 2012?
Your answer should be compact. 0.94. What is the ratio of the Borrowers(per 1000 adults) of Qatar in 2011 to that in 2012?
Offer a terse response. 0.97. What is the ratio of the Borrowers(per 1000 adults) of Tanzania in 2011 to that in 2012?
Ensure brevity in your answer.  1.3. What is the ratio of the Borrowers(per 1000 adults) in Europe(developing only) in 2011 to that in 2013?
Make the answer very short. 0.63. What is the ratio of the Borrowers(per 1000 adults) of Mauritania in 2011 to that in 2013?
Offer a very short reply. 0.86. What is the ratio of the Borrowers(per 1000 adults) of Qatar in 2011 to that in 2013?
Your answer should be compact. 0.93. What is the ratio of the Borrowers(per 1000 adults) in Tanzania in 2011 to that in 2013?
Make the answer very short. 1.43. What is the ratio of the Borrowers(per 1000 adults) in Europe(developing only) in 2011 to that in 2014?
Ensure brevity in your answer.  0.58. What is the ratio of the Borrowers(per 1000 adults) in Mauritania in 2011 to that in 2014?
Offer a very short reply. 0.11. What is the ratio of the Borrowers(per 1000 adults) of Qatar in 2011 to that in 2014?
Offer a terse response. 0.93. What is the ratio of the Borrowers(per 1000 adults) of Tanzania in 2011 to that in 2014?
Your answer should be very brief. 1.74. What is the ratio of the Borrowers(per 1000 adults) of Europe(developing only) in 2012 to that in 2013?
Keep it short and to the point. 0.69. What is the ratio of the Borrowers(per 1000 adults) of Mauritania in 2012 to that in 2013?
Give a very brief answer. 0.92. What is the ratio of the Borrowers(per 1000 adults) in Qatar in 2012 to that in 2013?
Ensure brevity in your answer.  0.96. What is the ratio of the Borrowers(per 1000 adults) of Tanzania in 2012 to that in 2013?
Offer a very short reply. 1.09. What is the ratio of the Borrowers(per 1000 adults) in Europe(developing only) in 2012 to that in 2014?
Provide a succinct answer. 0.64. What is the ratio of the Borrowers(per 1000 adults) in Mauritania in 2012 to that in 2014?
Keep it short and to the point. 0.12. What is the ratio of the Borrowers(per 1000 adults) in Qatar in 2012 to that in 2014?
Offer a terse response. 0.96. What is the ratio of the Borrowers(per 1000 adults) of Tanzania in 2012 to that in 2014?
Keep it short and to the point. 1.34. What is the ratio of the Borrowers(per 1000 adults) of Europe(developing only) in 2013 to that in 2014?
Make the answer very short. 0.92. What is the ratio of the Borrowers(per 1000 adults) in Mauritania in 2013 to that in 2014?
Your response must be concise. 0.13. What is the ratio of the Borrowers(per 1000 adults) in Qatar in 2013 to that in 2014?
Give a very brief answer. 1. What is the ratio of the Borrowers(per 1000 adults) in Tanzania in 2013 to that in 2014?
Keep it short and to the point. 1.22. What is the difference between the highest and the second highest Borrowers(per 1000 adults) in Europe(developing only)?
Your answer should be compact. 19.67. What is the difference between the highest and the second highest Borrowers(per 1000 adults) in Mauritania?
Make the answer very short. 8. What is the difference between the highest and the second highest Borrowers(per 1000 adults) in Qatar?
Offer a very short reply. 28.65. What is the difference between the highest and the second highest Borrowers(per 1000 adults) of Tanzania?
Your response must be concise. 2.91. What is the difference between the highest and the lowest Borrowers(per 1000 adults) of Europe(developing only)?
Provide a short and direct response. 134.19. What is the difference between the highest and the lowest Borrowers(per 1000 adults) of Mauritania?
Your answer should be very brief. 42.97. What is the difference between the highest and the lowest Borrowers(per 1000 adults) of Qatar?
Keep it short and to the point. 120.16. What is the difference between the highest and the lowest Borrowers(per 1000 adults) of Tanzania?
Provide a short and direct response. 15.03. 